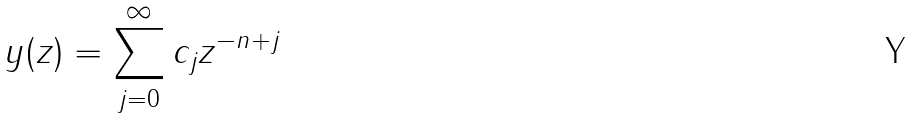Convert formula to latex. <formula><loc_0><loc_0><loc_500><loc_500>y ( z ) = \sum _ { j = 0 } ^ { \infty } c _ { j } z ^ { - n + j }</formula> 